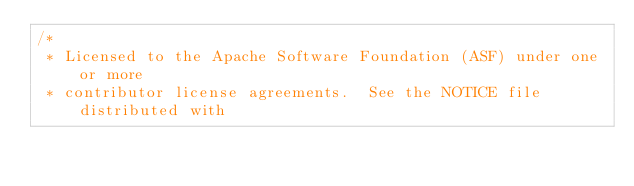<code> <loc_0><loc_0><loc_500><loc_500><_Java_>/*
 * Licensed to the Apache Software Foundation (ASF) under one or more
 * contributor license agreements.  See the NOTICE file distributed with</code> 